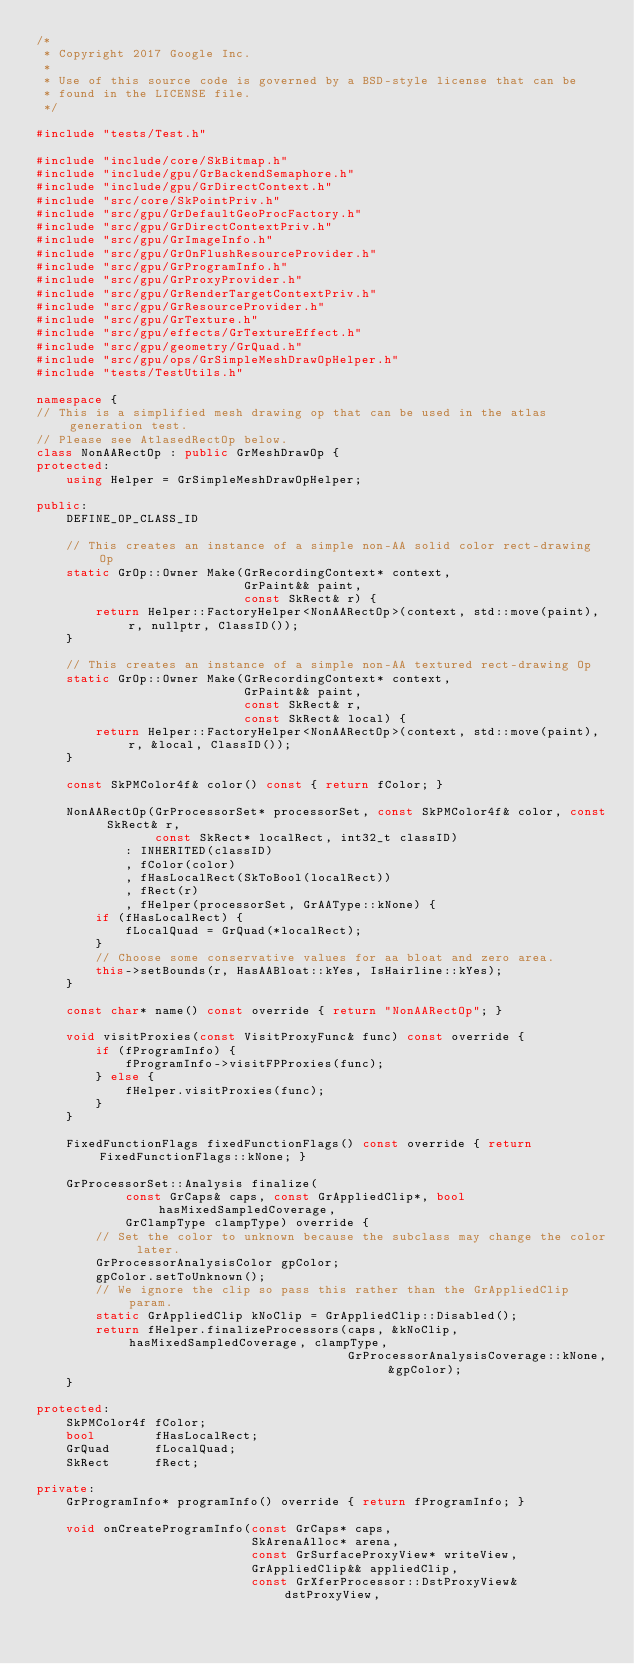<code> <loc_0><loc_0><loc_500><loc_500><_C++_>/*
 * Copyright 2017 Google Inc.
 *
 * Use of this source code is governed by a BSD-style license that can be
 * found in the LICENSE file.
 */

#include "tests/Test.h"

#include "include/core/SkBitmap.h"
#include "include/gpu/GrBackendSemaphore.h"
#include "include/gpu/GrDirectContext.h"
#include "src/core/SkPointPriv.h"
#include "src/gpu/GrDefaultGeoProcFactory.h"
#include "src/gpu/GrDirectContextPriv.h"
#include "src/gpu/GrImageInfo.h"
#include "src/gpu/GrOnFlushResourceProvider.h"
#include "src/gpu/GrProgramInfo.h"
#include "src/gpu/GrProxyProvider.h"
#include "src/gpu/GrRenderTargetContextPriv.h"
#include "src/gpu/GrResourceProvider.h"
#include "src/gpu/GrTexture.h"
#include "src/gpu/effects/GrTextureEffect.h"
#include "src/gpu/geometry/GrQuad.h"
#include "src/gpu/ops/GrSimpleMeshDrawOpHelper.h"
#include "tests/TestUtils.h"

namespace {
// This is a simplified mesh drawing op that can be used in the atlas generation test.
// Please see AtlasedRectOp below.
class NonAARectOp : public GrMeshDrawOp {
protected:
    using Helper = GrSimpleMeshDrawOpHelper;

public:
    DEFINE_OP_CLASS_ID

    // This creates an instance of a simple non-AA solid color rect-drawing Op
    static GrOp::Owner Make(GrRecordingContext* context,
                            GrPaint&& paint,
                            const SkRect& r) {
        return Helper::FactoryHelper<NonAARectOp>(context, std::move(paint), r, nullptr, ClassID());
    }

    // This creates an instance of a simple non-AA textured rect-drawing Op
    static GrOp::Owner Make(GrRecordingContext* context,
                            GrPaint&& paint,
                            const SkRect& r,
                            const SkRect& local) {
        return Helper::FactoryHelper<NonAARectOp>(context, std::move(paint), r, &local, ClassID());
    }

    const SkPMColor4f& color() const { return fColor; }

    NonAARectOp(GrProcessorSet* processorSet, const SkPMColor4f& color, const SkRect& r,
                const SkRect* localRect, int32_t classID)
            : INHERITED(classID)
            , fColor(color)
            , fHasLocalRect(SkToBool(localRect))
            , fRect(r)
            , fHelper(processorSet, GrAAType::kNone) {
        if (fHasLocalRect) {
            fLocalQuad = GrQuad(*localRect);
        }
        // Choose some conservative values for aa bloat and zero area.
        this->setBounds(r, HasAABloat::kYes, IsHairline::kYes);
    }

    const char* name() const override { return "NonAARectOp"; }

    void visitProxies(const VisitProxyFunc& func) const override {
        if (fProgramInfo) {
            fProgramInfo->visitFPProxies(func);
        } else {
            fHelper.visitProxies(func);
        }
    }

    FixedFunctionFlags fixedFunctionFlags() const override { return FixedFunctionFlags::kNone; }

    GrProcessorSet::Analysis finalize(
            const GrCaps& caps, const GrAppliedClip*, bool hasMixedSampledCoverage,
            GrClampType clampType) override {
        // Set the color to unknown because the subclass may change the color later.
        GrProcessorAnalysisColor gpColor;
        gpColor.setToUnknown();
        // We ignore the clip so pass this rather than the GrAppliedClip param.
        static GrAppliedClip kNoClip = GrAppliedClip::Disabled();
        return fHelper.finalizeProcessors(caps, &kNoClip, hasMixedSampledCoverage, clampType,
                                          GrProcessorAnalysisCoverage::kNone, &gpColor);
    }

protected:
    SkPMColor4f fColor;
    bool        fHasLocalRect;
    GrQuad      fLocalQuad;
    SkRect      fRect;

private:
    GrProgramInfo* programInfo() override { return fProgramInfo; }

    void onCreateProgramInfo(const GrCaps* caps,
                             SkArenaAlloc* arena,
                             const GrSurfaceProxyView* writeView,
                             GrAppliedClip&& appliedClip,
                             const GrXferProcessor::DstProxyView& dstProxyView,</code> 